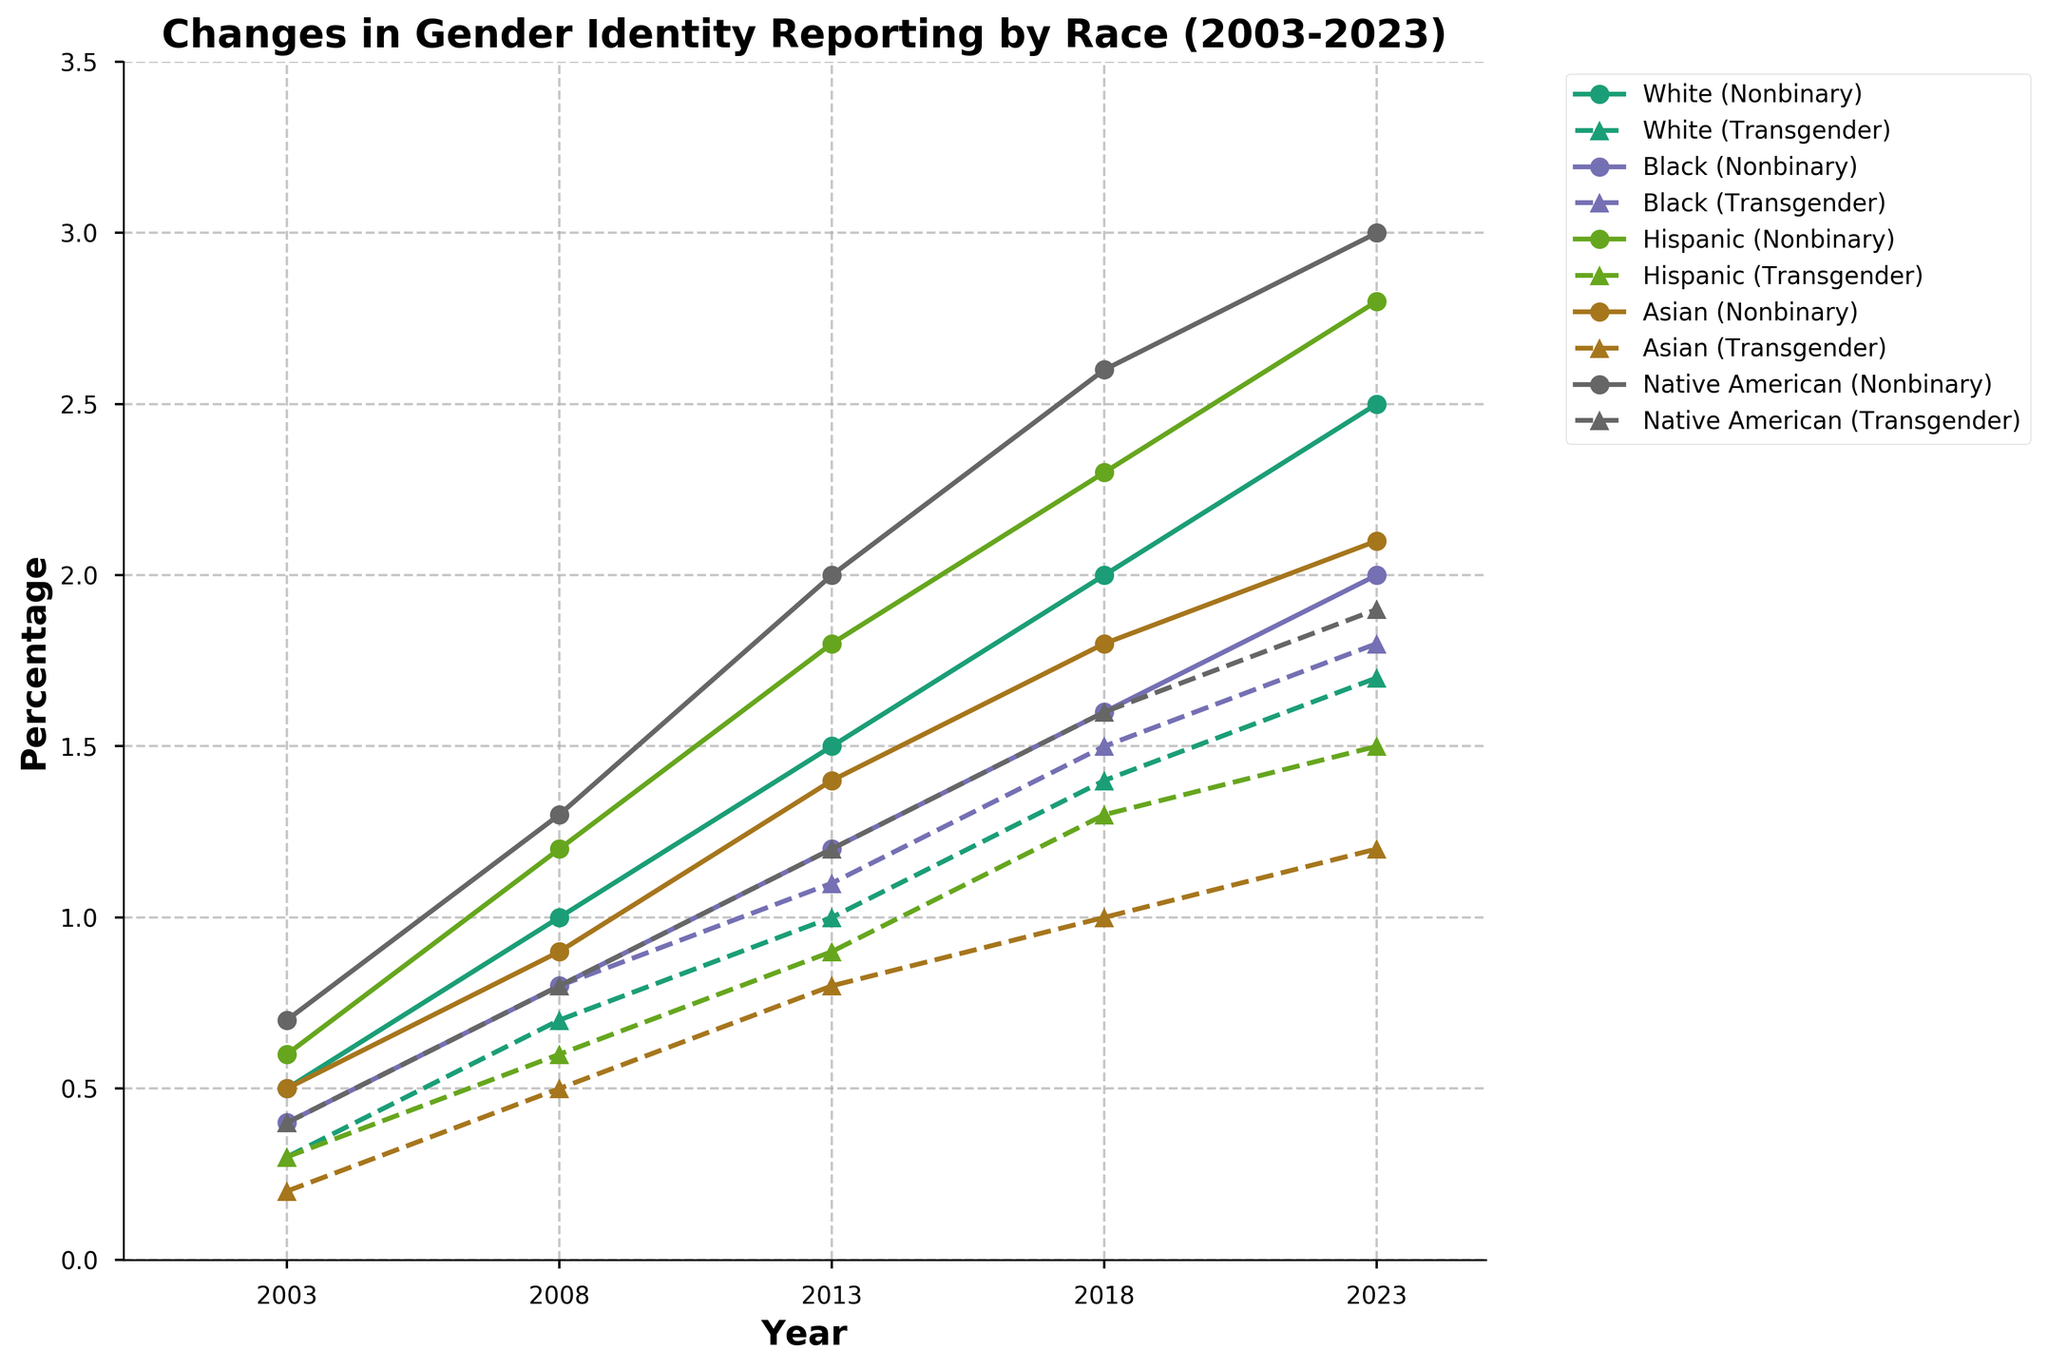What is the highest percentage of identifying as nonbinary recorded among all races? By examining all lines marked with circles on the plot, the Native American group in 2023 shows the highest percentage identifying as nonbinary at 3.0%.
Answer: 3.0% Which race shows the most significant increase in the percentage identifying as nonbinary from 2003 to 2023? To identify this, compare the starting and ending points of the nonbinary percentage for each race. Native American increases from 0.7% in 2003 to 3.0% in 2023, which is the highest increase of 2.3%.
Answer: Native American Between 2003 and 2023, how did the percentage of identifying as transgender among Black individuals change? Look at the plot for the line with triangles for the Black group. In 2003, it's 0.4%, and in 2023, it's 1.8%, showing an increase of 1.4%.
Answer: Increased by 1.4% Which year shows the largest gap between percentages identifying as nonbinary and transgender for the Asian group? For the Asian group, compute the difference between nonbinary and transgender percentages for each year: 2003 (0.5% - 0.2% = 0.3%), 2008 (0.9% - 0.5% = 0.4%), 2013 (1.4% - 0.8% = 0.6%), 2018 (1.8% - 1.0% = 0.8%), and 2023 (2.1% - 1.2% = 0.9%). The largest gap is in 2023 with 0.9%.
Answer: 2023 In which year did the White race reach a 2.0% identification as nonbinary? Follow the line with circles marked for the White group and see that in 2018, the nonbinary percentage reaches 2.0%.
Answer: 2018 Among Hispanic individuals, during which period did the percentage identifying as transgender not change? Observe the triangle-marked line for Hispanic individuals. From 2003 to 2008, it remains constant at 0.3%.
Answer: 2003 to 2008 How does the percentage of Native Americans identifying as transgender in 2023 compare to their percentage in 2003? The triangle-marked line for Native Americans shows 0.4% in 2003 and 1.9% in 2023. Subtract 0.4% from 1.9% to get an increase of 1.5%.
Answer: Increased by 1.5% What trend can be observed for the percentage of Asian individuals identifying as nonbinary over the years? The circle-marked line for Asians shows a consistent rise every year from 0.5% in 2003 to 2.1% in 2023, indicating an upward trend.
Answer: Upward trend 